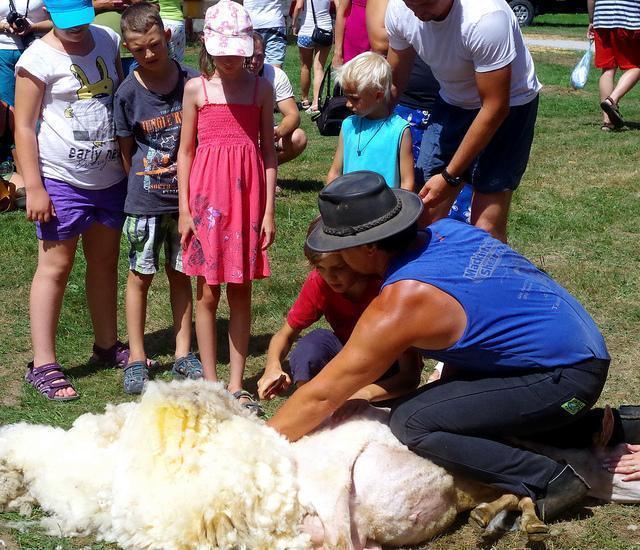Why is the animal on the ground?
Pick the correct solution from the four options below to address the question.
Options: Sleeping, shearing, killing, birthing. Shearing. 